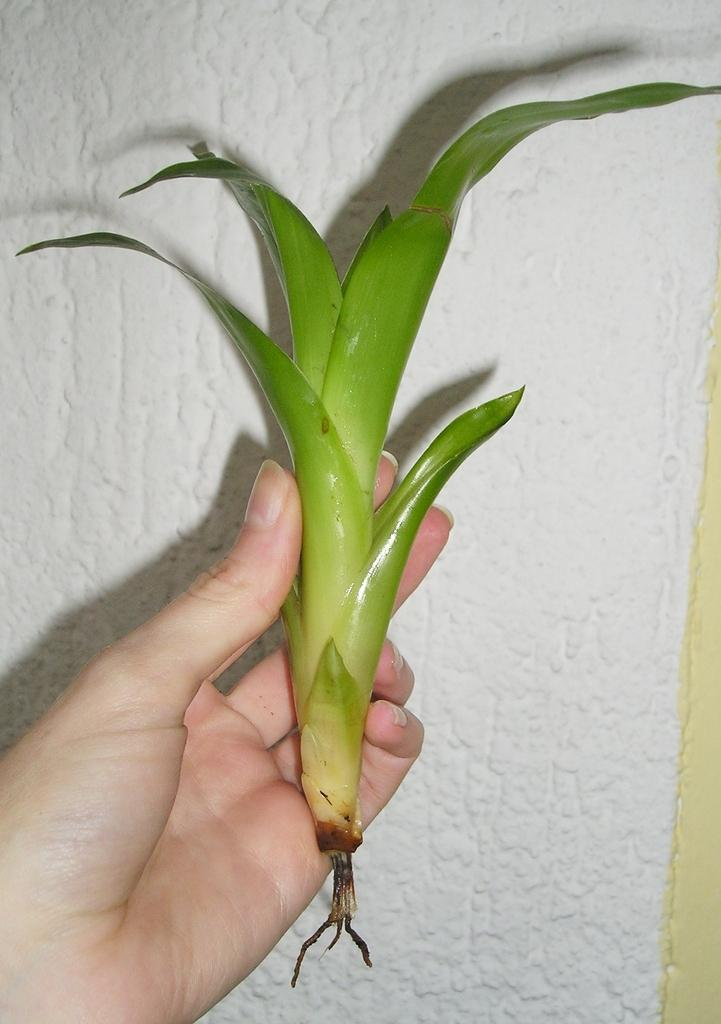Who or what is the main subject in the image? There is a person in the image. What is the person holding in the image? The person is holding a green color plant. Can you describe the background of the image? The background of the image is white and cream color. What level of the building is the person standing on in the image? There is no indication of a building or a specific level in the image; it only shows a person holding a green color plant against a white and cream background. 